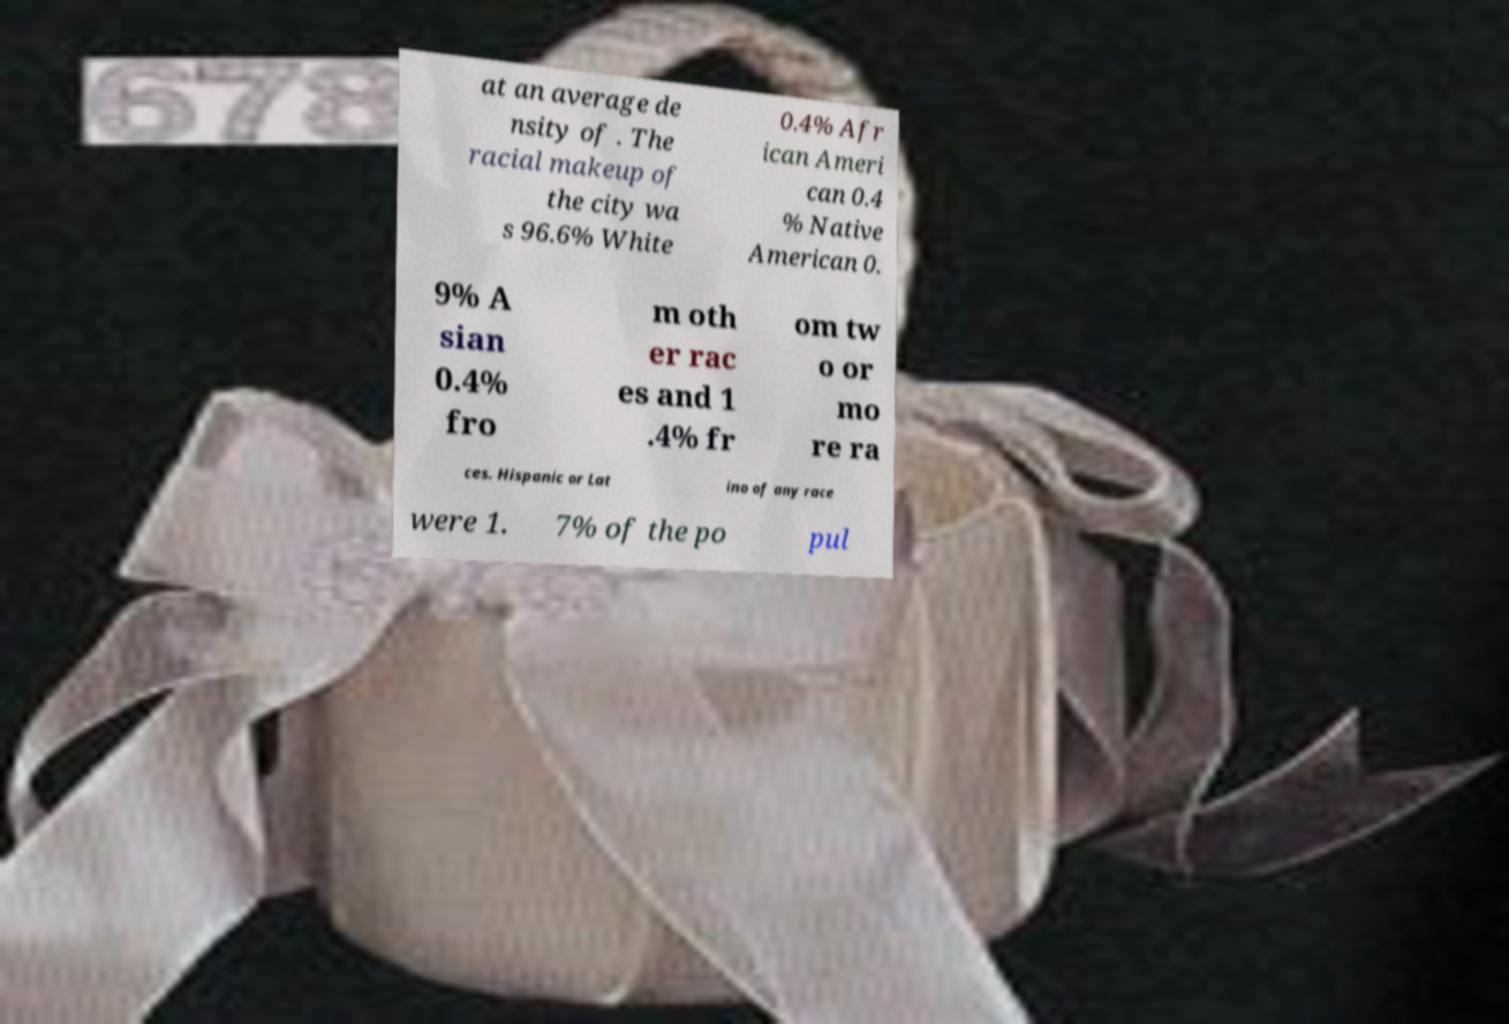Can you read and provide the text displayed in the image?This photo seems to have some interesting text. Can you extract and type it out for me? at an average de nsity of . The racial makeup of the city wa s 96.6% White 0.4% Afr ican Ameri can 0.4 % Native American 0. 9% A sian 0.4% fro m oth er rac es and 1 .4% fr om tw o or mo re ra ces. Hispanic or Lat ino of any race were 1. 7% of the po pul 